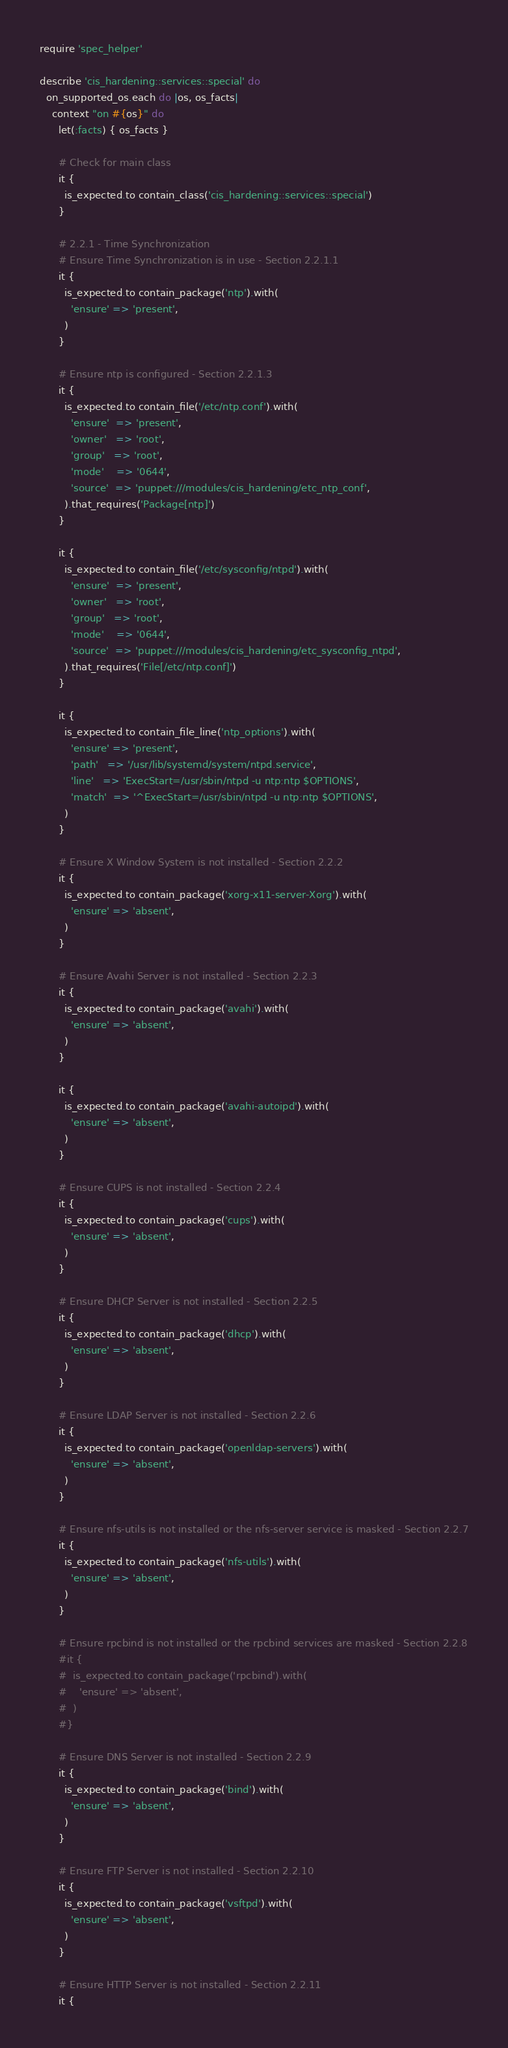<code> <loc_0><loc_0><loc_500><loc_500><_Ruby_>require 'spec_helper'

describe 'cis_hardening::services::special' do
  on_supported_os.each do |os, os_facts|
    context "on #{os}" do
      let(:facts) { os_facts }

      # Check for main class
      it {
        is_expected.to contain_class('cis_hardening::services::special')
      }

      # 2.2.1 - Time Synchronization
      # Ensure Time Synchronization is in use - Section 2.2.1.1
      it {
        is_expected.to contain_package('ntp').with(
          'ensure' => 'present',
        )
      }

      # Ensure ntp is configured - Section 2.2.1.3
      it {
        is_expected.to contain_file('/etc/ntp.conf').with(
          'ensure'  => 'present',
          'owner'   => 'root',
          'group'   => 'root',
          'mode'    => '0644',
          'source'  => 'puppet:///modules/cis_hardening/etc_ntp_conf',
        ).that_requires('Package[ntp]')
      }

      it {
        is_expected.to contain_file('/etc/sysconfig/ntpd').with(
          'ensure'  => 'present',
          'owner'   => 'root',
          'group'   => 'root',
          'mode'    => '0644',
          'source'  => 'puppet:///modules/cis_hardening/etc_sysconfig_ntpd',
        ).that_requires('File[/etc/ntp.conf]')
      }

      it {
        is_expected.to contain_file_line('ntp_options').with(
          'ensure' => 'present',
          'path'   => '/usr/lib/systemd/system/ntpd.service',
          'line'   => 'ExecStart=/usr/sbin/ntpd -u ntp:ntp $OPTIONS',
          'match'  => '^ExecStart=/usr/sbin/ntpd -u ntp:ntp $OPTIONS',
        )
      }

      # Ensure X Window System is not installed - Section 2.2.2
      it {
        is_expected.to contain_package('xorg-x11-server-Xorg').with(
          'ensure' => 'absent',
        )
      }

      # Ensure Avahi Server is not installed - Section 2.2.3
      it {
        is_expected.to contain_package('avahi').with(
          'ensure' => 'absent',
        )
      }

      it {
        is_expected.to contain_package('avahi-autoipd').with(
          'ensure' => 'absent',
        )
      }

      # Ensure CUPS is not installed - Section 2.2.4
      it {
        is_expected.to contain_package('cups').with(
          'ensure' => 'absent',
        )
      }

      # Ensure DHCP Server is not installed - Section 2.2.5
      it {
        is_expected.to contain_package('dhcp').with(
          'ensure' => 'absent',
        )
      }

      # Ensure LDAP Server is not installed - Section 2.2.6
      it {
        is_expected.to contain_package('openldap-servers').with(
          'ensure' => 'absent',
        )
      }

      # Ensure nfs-utils is not installed or the nfs-server service is masked - Section 2.2.7
      it {
        is_expected.to contain_package('nfs-utils').with(
          'ensure' => 'absent',
        )
      }

      # Ensure rpcbind is not installed or the rpcbind services are masked - Section 2.2.8
      #it {
      #  is_expected.to contain_package('rpcbind').with(
      #    'ensure' => 'absent',
      #  )
      #}

      # Ensure DNS Server is not installed - Section 2.2.9
      it {
        is_expected.to contain_package('bind').with(
          'ensure' => 'absent',
        )
      }

      # Ensure FTP Server is not installed - Section 2.2.10
      it {
        is_expected.to contain_package('vsftpd').with(
          'ensure' => 'absent',
        )
      }

      # Ensure HTTP Server is not installed - Section 2.2.11
      it {</code> 